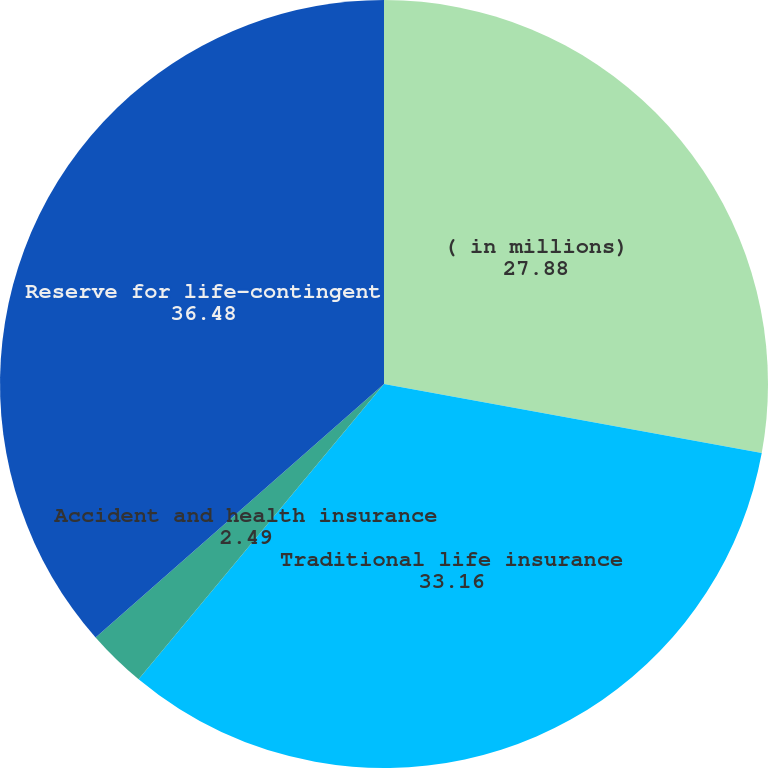Convert chart. <chart><loc_0><loc_0><loc_500><loc_500><pie_chart><fcel>( in millions)<fcel>Traditional life insurance<fcel>Accident and health insurance<fcel>Reserve for life-contingent<nl><fcel>27.88%<fcel>33.16%<fcel>2.49%<fcel>36.48%<nl></chart> 